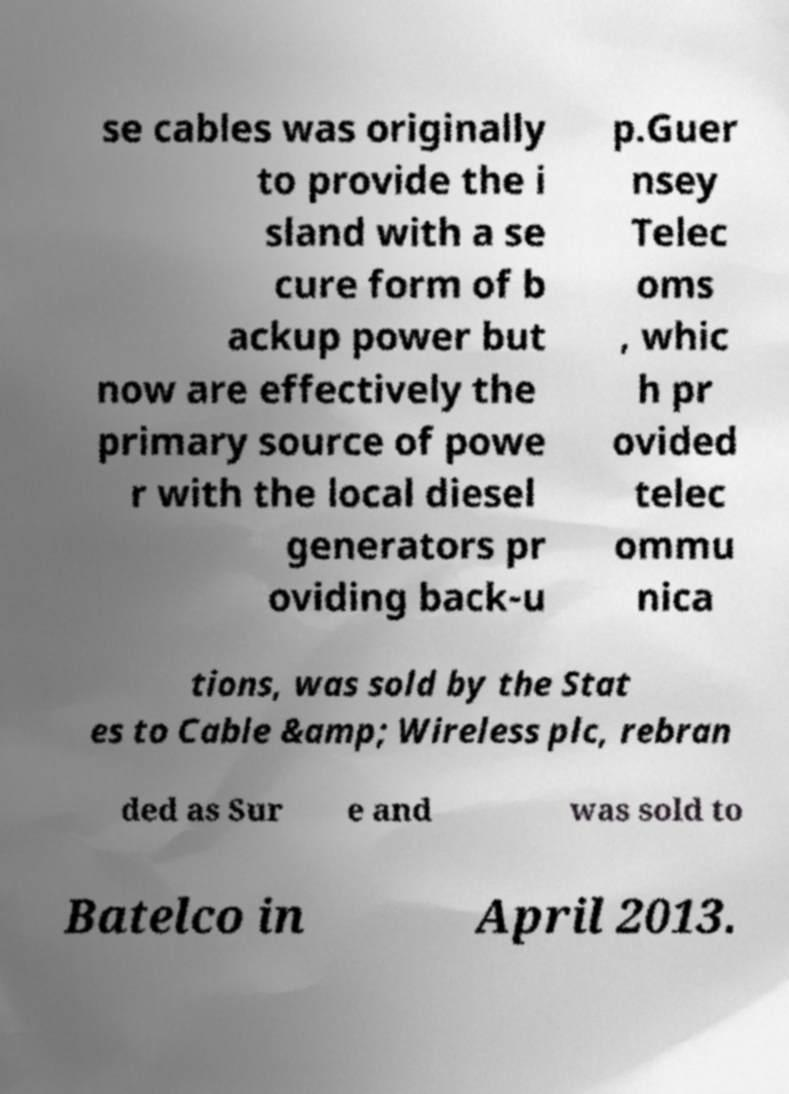Please read and relay the text visible in this image. What does it say? se cables was originally to provide the i sland with a se cure form of b ackup power but now are effectively the primary source of powe r with the local diesel generators pr oviding back-u p.Guer nsey Telec oms , whic h pr ovided telec ommu nica tions, was sold by the Stat es to Cable &amp; Wireless plc, rebran ded as Sur e and was sold to Batelco in April 2013. 